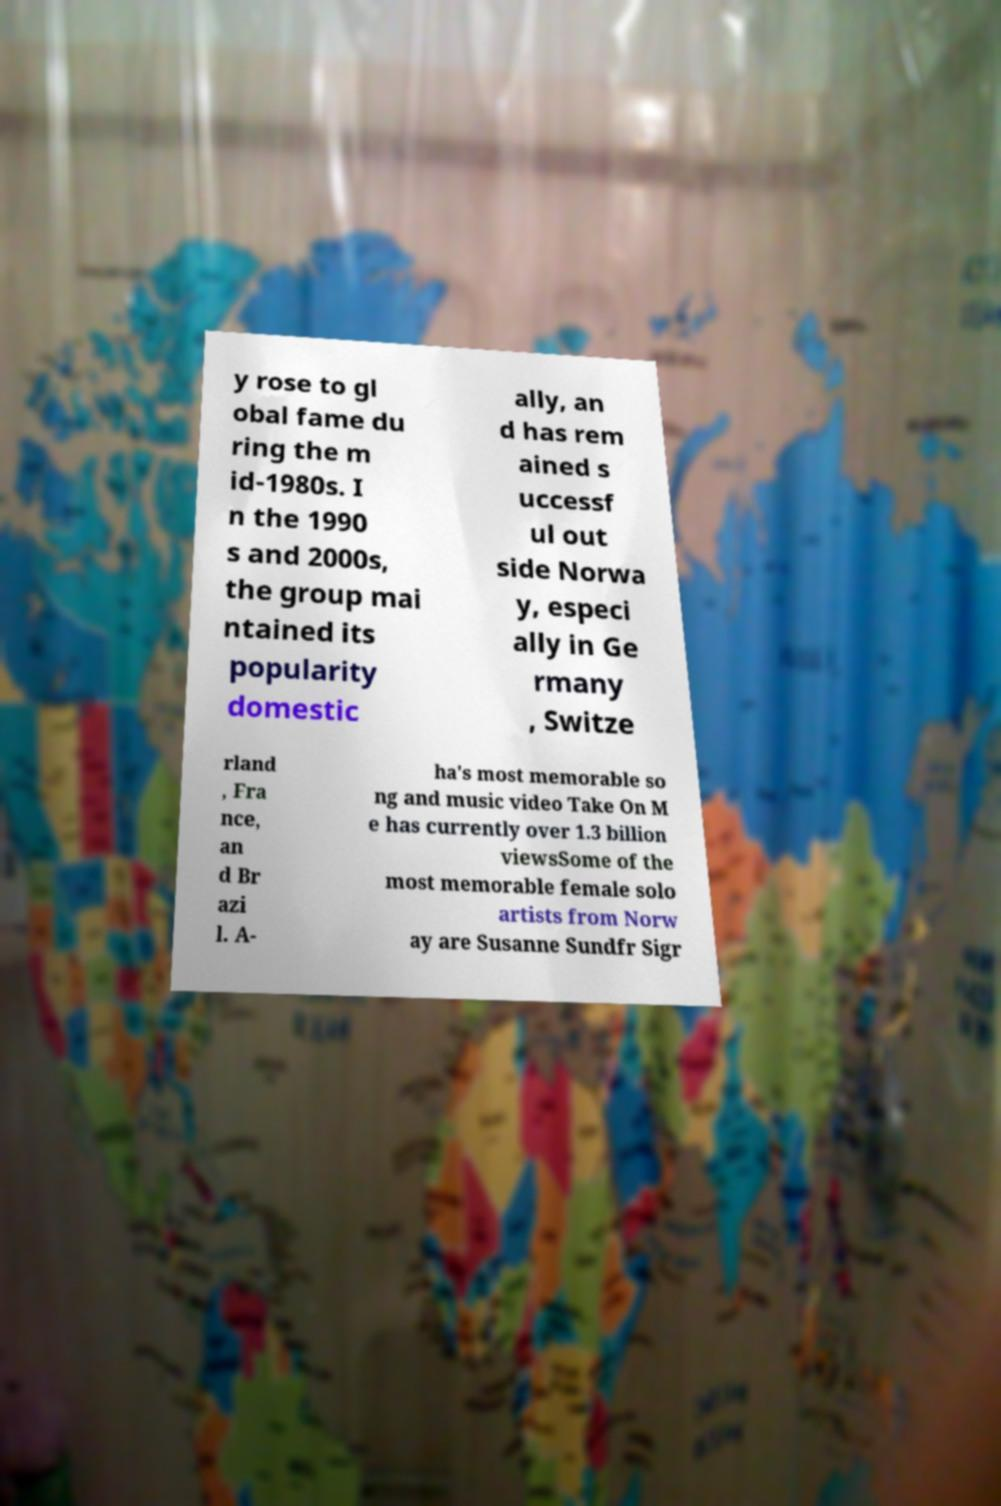Please read and relay the text visible in this image. What does it say? y rose to gl obal fame du ring the m id-1980s. I n the 1990 s and 2000s, the group mai ntained its popularity domestic ally, an d has rem ained s uccessf ul out side Norwa y, especi ally in Ge rmany , Switze rland , Fra nce, an d Br azi l. A- ha's most memorable so ng and music video Take On M e has currently over 1.3 billion viewsSome of the most memorable female solo artists from Norw ay are Susanne Sundfr Sigr 